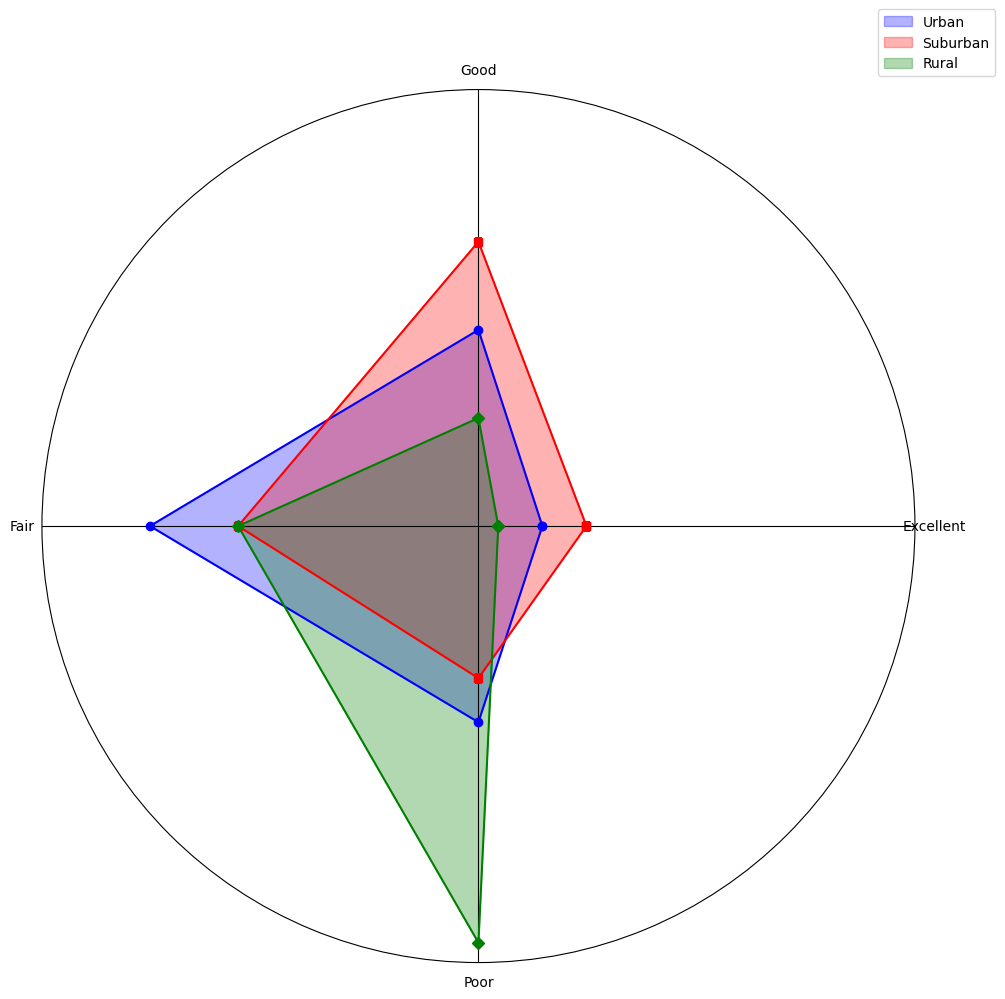What rating category has the highest number of schools in rural areas? To determine this, look at the green area with the highest length in the 'Rural' part of the rose chart. The 'Poor' category has the largest segment in Rural areas.
Answer: Poor Which infrastructure quality rating is equally common in both urban and rural areas? Compare the lengths of the blue and green segments to identify any equal lengths. The 'Fair' category has the same length in both Urban and Rural areas.
Answer: Fair How does the proportion of 'Excellent' ratings in suburban areas compare to urban areas? Inspect the lengths of the red segment for 'Excellent' in suburban areas and the blue segment for 'Excellent' in urban areas. The red segment for suburban areas is longer than the blue segment.
Answer: Suburban has a higher proportion What is the visual difference between the 'Good' ratings in urban and rural areas? Compare the lengths of the blue segment (urban) and green segment (rural) for the 'Good' category. The 'Good' segment in Urban areas is longer than in Rural areas.
Answer: Urban is larger If you sum the 'Good' and 'Excellent' ratings in suburban areas, which category does it surpass in the same area? Identify and sum the lengths of the red segments for 'Good' and 'Excellent' in suburban areas, then compare to the lengths of other red segments. Summing 'Good' (35) and 'Excellent' (15) is 50, which surpasses 'Poor' (20) but is not larger than 'Fair' (30).
Answer: Poor How do the proportions of 'Fair' ratings compare across urban, suburban, and rural areas? Examine the lengths of the blue, red, and green segments for 'Fair' in each area. The blue, red, and green segments are close, but urban and rural are longer than suburban.
Answer: Urban = Rural > Suburban Which area has the largest proportion of 'Poor' infrastructure ratings? Inspect the lengths of the blue, red, and green segments for the 'Poor' category. The green segment in Rural is the longest, indicating the largest proportion of 'Poor' ratings.
Answer: Rural By what amount does the number of 'Poor' ratings in rural areas exceed those in urban areas? Look at the lengths of the green (rural) and blue (urban) segments for 'Poor' ratings. The value for Rural is 50 and for Urban is 25. The difference is 50 - 25.
Answer: 25 